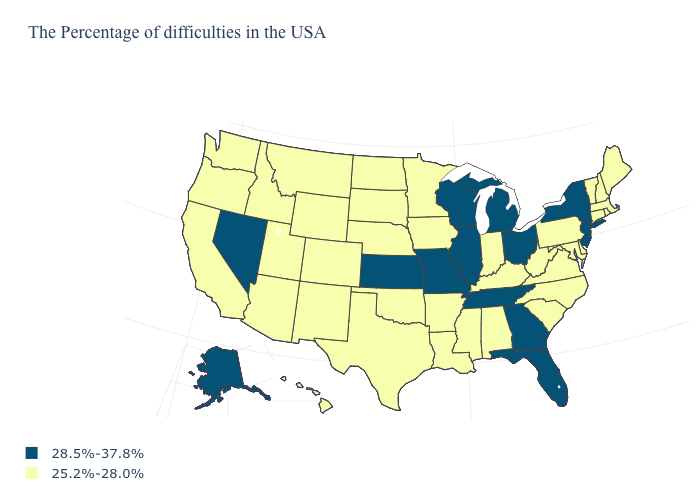What is the value of South Dakota?
Short answer required. 25.2%-28.0%. What is the value of Kansas?
Keep it brief. 28.5%-37.8%. What is the value of Wisconsin?
Give a very brief answer. 28.5%-37.8%. Which states have the lowest value in the West?
Give a very brief answer. Wyoming, Colorado, New Mexico, Utah, Montana, Arizona, Idaho, California, Washington, Oregon, Hawaii. Which states hav the highest value in the South?
Short answer required. Florida, Georgia, Tennessee. Is the legend a continuous bar?
Concise answer only. No. Is the legend a continuous bar?
Keep it brief. No. Name the states that have a value in the range 28.5%-37.8%?
Write a very short answer. New York, New Jersey, Ohio, Florida, Georgia, Michigan, Tennessee, Wisconsin, Illinois, Missouri, Kansas, Nevada, Alaska. Does Nevada have the lowest value in the West?
Write a very short answer. No. Does the map have missing data?
Keep it brief. No. Does South Dakota have the highest value in the USA?
Quick response, please. No. Does the map have missing data?
Keep it brief. No. What is the value of Iowa?
Answer briefly. 25.2%-28.0%. What is the lowest value in the USA?
Concise answer only. 25.2%-28.0%. What is the value of Virginia?
Answer briefly. 25.2%-28.0%. 